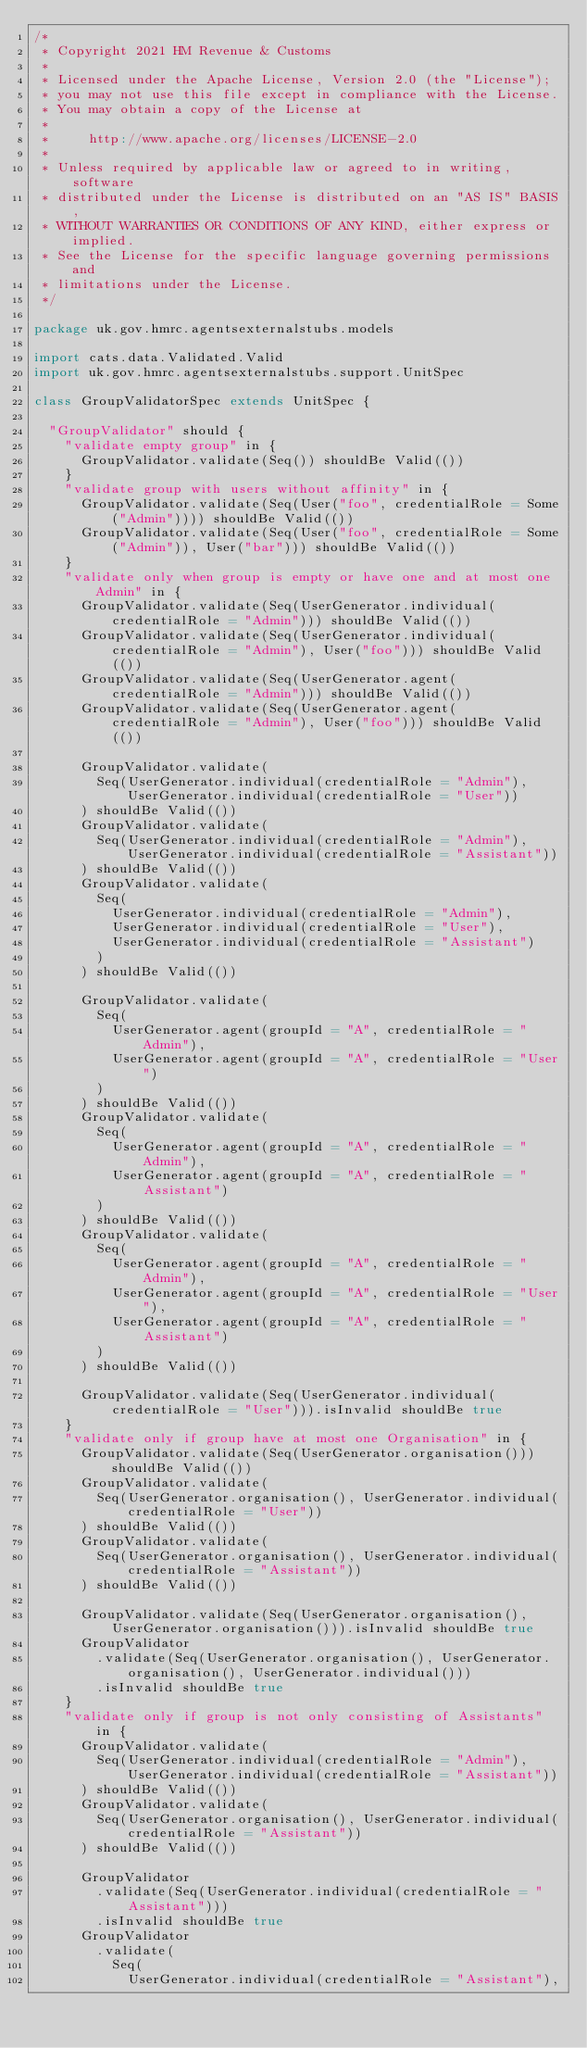Convert code to text. <code><loc_0><loc_0><loc_500><loc_500><_Scala_>/*
 * Copyright 2021 HM Revenue & Customs
 *
 * Licensed under the Apache License, Version 2.0 (the "License");
 * you may not use this file except in compliance with the License.
 * You may obtain a copy of the License at
 *
 *     http://www.apache.org/licenses/LICENSE-2.0
 *
 * Unless required by applicable law or agreed to in writing, software
 * distributed under the License is distributed on an "AS IS" BASIS,
 * WITHOUT WARRANTIES OR CONDITIONS OF ANY KIND, either express or implied.
 * See the License for the specific language governing permissions and
 * limitations under the License.
 */

package uk.gov.hmrc.agentsexternalstubs.models

import cats.data.Validated.Valid
import uk.gov.hmrc.agentsexternalstubs.support.UnitSpec

class GroupValidatorSpec extends UnitSpec {

  "GroupValidator" should {
    "validate empty group" in {
      GroupValidator.validate(Seq()) shouldBe Valid(())
    }
    "validate group with users without affinity" in {
      GroupValidator.validate(Seq(User("foo", credentialRole = Some("Admin")))) shouldBe Valid(())
      GroupValidator.validate(Seq(User("foo", credentialRole = Some("Admin")), User("bar"))) shouldBe Valid(())
    }
    "validate only when group is empty or have one and at most one Admin" in {
      GroupValidator.validate(Seq(UserGenerator.individual(credentialRole = "Admin"))) shouldBe Valid(())
      GroupValidator.validate(Seq(UserGenerator.individual(credentialRole = "Admin"), User("foo"))) shouldBe Valid(())
      GroupValidator.validate(Seq(UserGenerator.agent(credentialRole = "Admin"))) shouldBe Valid(())
      GroupValidator.validate(Seq(UserGenerator.agent(credentialRole = "Admin"), User("foo"))) shouldBe Valid(())

      GroupValidator.validate(
        Seq(UserGenerator.individual(credentialRole = "Admin"), UserGenerator.individual(credentialRole = "User"))
      ) shouldBe Valid(())
      GroupValidator.validate(
        Seq(UserGenerator.individual(credentialRole = "Admin"), UserGenerator.individual(credentialRole = "Assistant"))
      ) shouldBe Valid(())
      GroupValidator.validate(
        Seq(
          UserGenerator.individual(credentialRole = "Admin"),
          UserGenerator.individual(credentialRole = "User"),
          UserGenerator.individual(credentialRole = "Assistant")
        )
      ) shouldBe Valid(())

      GroupValidator.validate(
        Seq(
          UserGenerator.agent(groupId = "A", credentialRole = "Admin"),
          UserGenerator.agent(groupId = "A", credentialRole = "User")
        )
      ) shouldBe Valid(())
      GroupValidator.validate(
        Seq(
          UserGenerator.agent(groupId = "A", credentialRole = "Admin"),
          UserGenerator.agent(groupId = "A", credentialRole = "Assistant")
        )
      ) shouldBe Valid(())
      GroupValidator.validate(
        Seq(
          UserGenerator.agent(groupId = "A", credentialRole = "Admin"),
          UserGenerator.agent(groupId = "A", credentialRole = "User"),
          UserGenerator.agent(groupId = "A", credentialRole = "Assistant")
        )
      ) shouldBe Valid(())

      GroupValidator.validate(Seq(UserGenerator.individual(credentialRole = "User"))).isInvalid shouldBe true
    }
    "validate only if group have at most one Organisation" in {
      GroupValidator.validate(Seq(UserGenerator.organisation())) shouldBe Valid(())
      GroupValidator.validate(
        Seq(UserGenerator.organisation(), UserGenerator.individual(credentialRole = "User"))
      ) shouldBe Valid(())
      GroupValidator.validate(
        Seq(UserGenerator.organisation(), UserGenerator.individual(credentialRole = "Assistant"))
      ) shouldBe Valid(())

      GroupValidator.validate(Seq(UserGenerator.organisation(), UserGenerator.organisation())).isInvalid shouldBe true
      GroupValidator
        .validate(Seq(UserGenerator.organisation(), UserGenerator.organisation(), UserGenerator.individual()))
        .isInvalid shouldBe true
    }
    "validate only if group is not only consisting of Assistants" in {
      GroupValidator.validate(
        Seq(UserGenerator.individual(credentialRole = "Admin"), UserGenerator.individual(credentialRole = "Assistant"))
      ) shouldBe Valid(())
      GroupValidator.validate(
        Seq(UserGenerator.organisation(), UserGenerator.individual(credentialRole = "Assistant"))
      ) shouldBe Valid(())

      GroupValidator
        .validate(Seq(UserGenerator.individual(credentialRole = "Assistant")))
        .isInvalid shouldBe true
      GroupValidator
        .validate(
          Seq(
            UserGenerator.individual(credentialRole = "Assistant"),</code> 